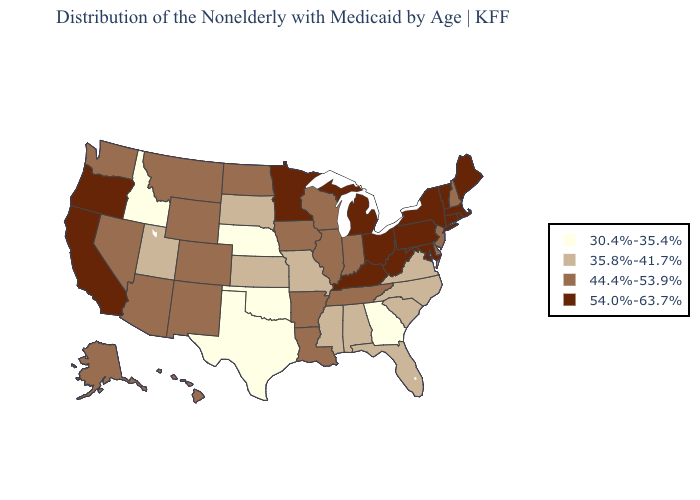Which states have the lowest value in the USA?
Concise answer only. Georgia, Idaho, Nebraska, Oklahoma, Texas. What is the value of Vermont?
Concise answer only. 54.0%-63.7%. Does Alabama have a lower value than Pennsylvania?
Quick response, please. Yes. Does Missouri have a lower value than New Jersey?
Write a very short answer. Yes. What is the value of Oregon?
Concise answer only. 54.0%-63.7%. Name the states that have a value in the range 44.4%-53.9%?
Concise answer only. Alaska, Arizona, Arkansas, Colorado, Delaware, Hawaii, Illinois, Indiana, Iowa, Louisiana, Montana, Nevada, New Hampshire, New Jersey, New Mexico, North Dakota, Tennessee, Washington, Wisconsin, Wyoming. Name the states that have a value in the range 30.4%-35.4%?
Quick response, please. Georgia, Idaho, Nebraska, Oklahoma, Texas. Does Nevada have the lowest value in the USA?
Keep it brief. No. Name the states that have a value in the range 30.4%-35.4%?
Short answer required. Georgia, Idaho, Nebraska, Oklahoma, Texas. What is the highest value in the USA?
Give a very brief answer. 54.0%-63.7%. What is the value of Montana?
Answer briefly. 44.4%-53.9%. Name the states that have a value in the range 30.4%-35.4%?
Concise answer only. Georgia, Idaho, Nebraska, Oklahoma, Texas. Which states have the highest value in the USA?
Keep it brief. California, Connecticut, Kentucky, Maine, Maryland, Massachusetts, Michigan, Minnesota, New York, Ohio, Oregon, Pennsylvania, Rhode Island, Vermont, West Virginia. Does South Dakota have a higher value than Maryland?
Short answer required. No. Does the map have missing data?
Concise answer only. No. 